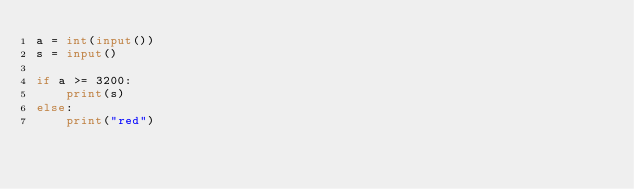Convert code to text. <code><loc_0><loc_0><loc_500><loc_500><_Python_>a = int(input())
s = input()

if a >= 3200:
    print(s)
else:
    print("red")</code> 